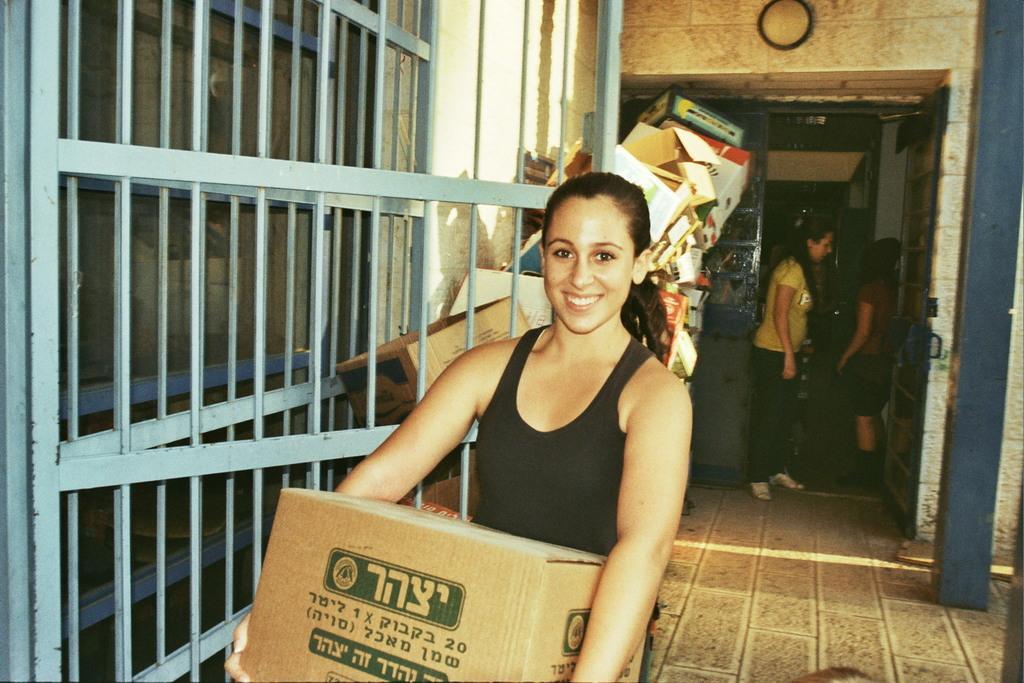In one or two sentences, can you explain what this image depicts? In this image we can see a woman holding an object in the foreground. Behind the woman we can see a group of objects. On the right side, we can see two persons, a wall and a pillar. On the left side, we can see grills, glass and a wall. At the top we can see an object in a circular shape. 